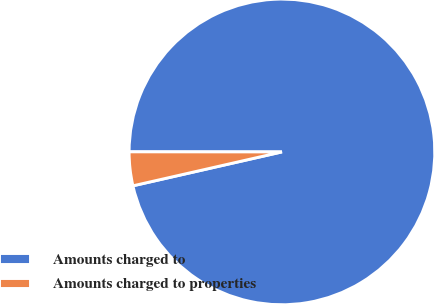Convert chart to OTSL. <chart><loc_0><loc_0><loc_500><loc_500><pie_chart><fcel>Amounts charged to<fcel>Amounts charged to properties<nl><fcel>96.43%<fcel>3.57%<nl></chart> 